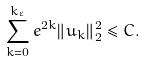Convert formula to latex. <formula><loc_0><loc_0><loc_500><loc_500>\sum _ { k = 0 } ^ { k _ { \varepsilon } } e ^ { 2 k } \| u _ { k } \| ^ { 2 } _ { 2 } \leq C .</formula> 